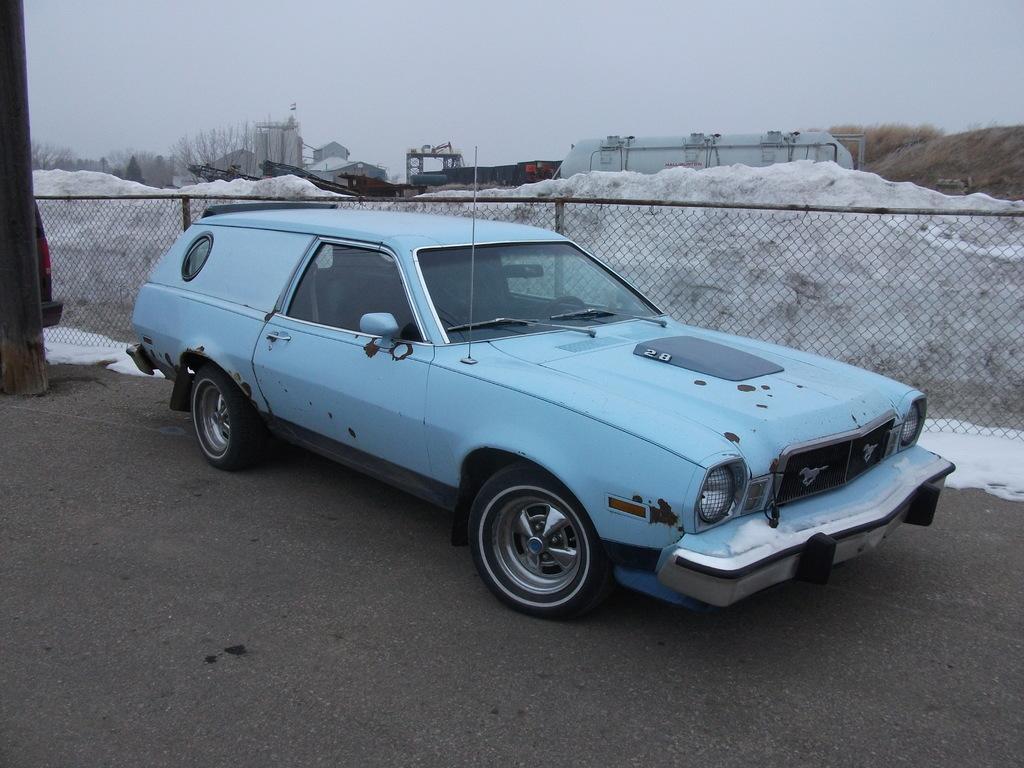Can you describe this image briefly? In the center of the image there is a blue color car on the road. There is a fencing. In the background of the image there are vehicles. At the bottom of the image there is road. There is snow. 